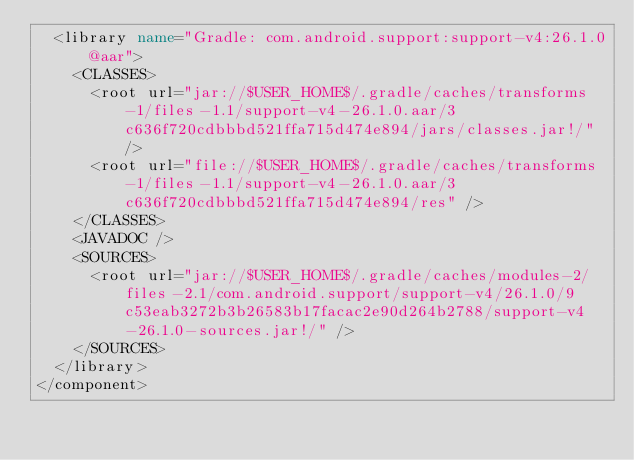Convert code to text. <code><loc_0><loc_0><loc_500><loc_500><_XML_>  <library name="Gradle: com.android.support:support-v4:26.1.0@aar">
    <CLASSES>
      <root url="jar://$USER_HOME$/.gradle/caches/transforms-1/files-1.1/support-v4-26.1.0.aar/3c636f720cdbbbd521ffa715d474e894/jars/classes.jar!/" />
      <root url="file://$USER_HOME$/.gradle/caches/transforms-1/files-1.1/support-v4-26.1.0.aar/3c636f720cdbbbd521ffa715d474e894/res" />
    </CLASSES>
    <JAVADOC />
    <SOURCES>
      <root url="jar://$USER_HOME$/.gradle/caches/modules-2/files-2.1/com.android.support/support-v4/26.1.0/9c53eab3272b3b26583b17facac2e90d264b2788/support-v4-26.1.0-sources.jar!/" />
    </SOURCES>
  </library>
</component></code> 